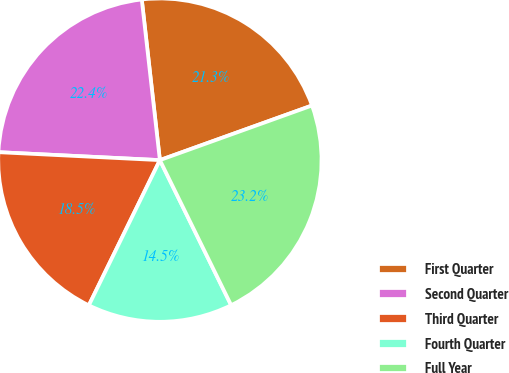Convert chart to OTSL. <chart><loc_0><loc_0><loc_500><loc_500><pie_chart><fcel>First Quarter<fcel>Second Quarter<fcel>Third Quarter<fcel>Fourth Quarter<fcel>Full Year<nl><fcel>21.3%<fcel>22.43%<fcel>18.54%<fcel>14.51%<fcel>23.22%<nl></chart> 